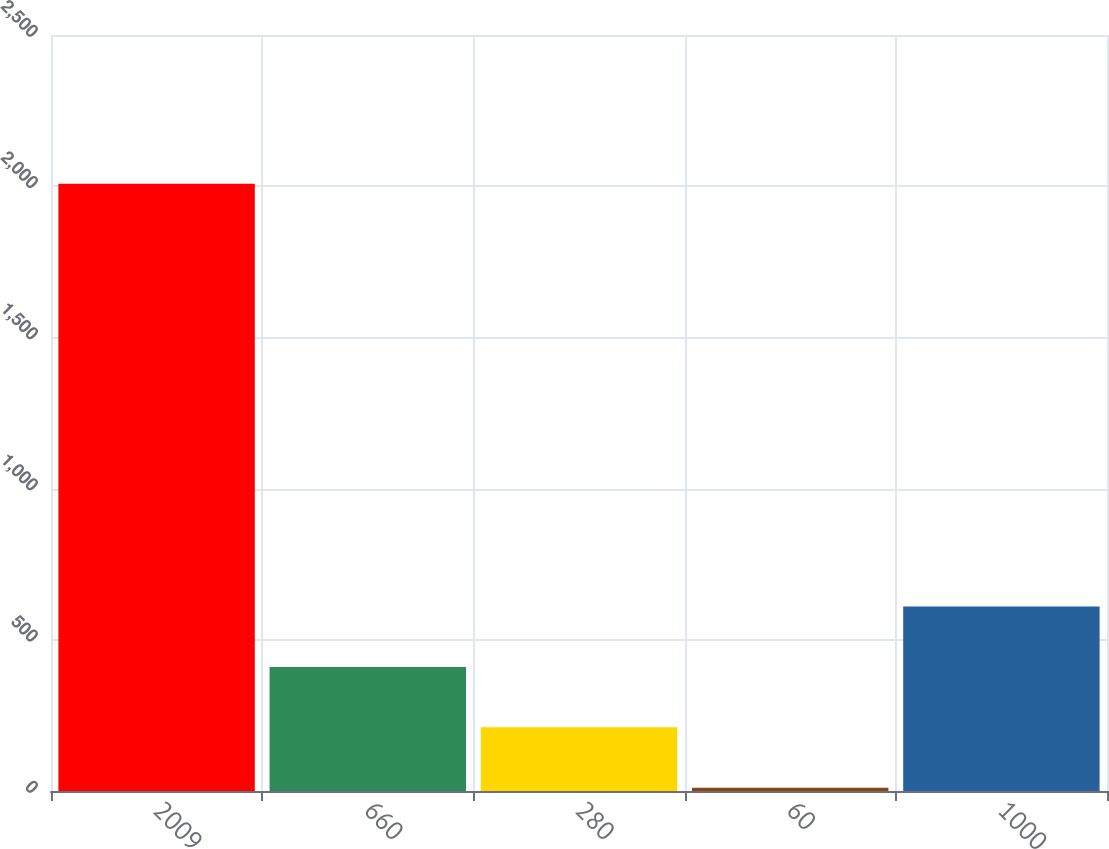<chart> <loc_0><loc_0><loc_500><loc_500><bar_chart><fcel>2009<fcel>660<fcel>280<fcel>60<fcel>1000<nl><fcel>2008<fcel>410.4<fcel>210.7<fcel>11<fcel>610.1<nl></chart> 